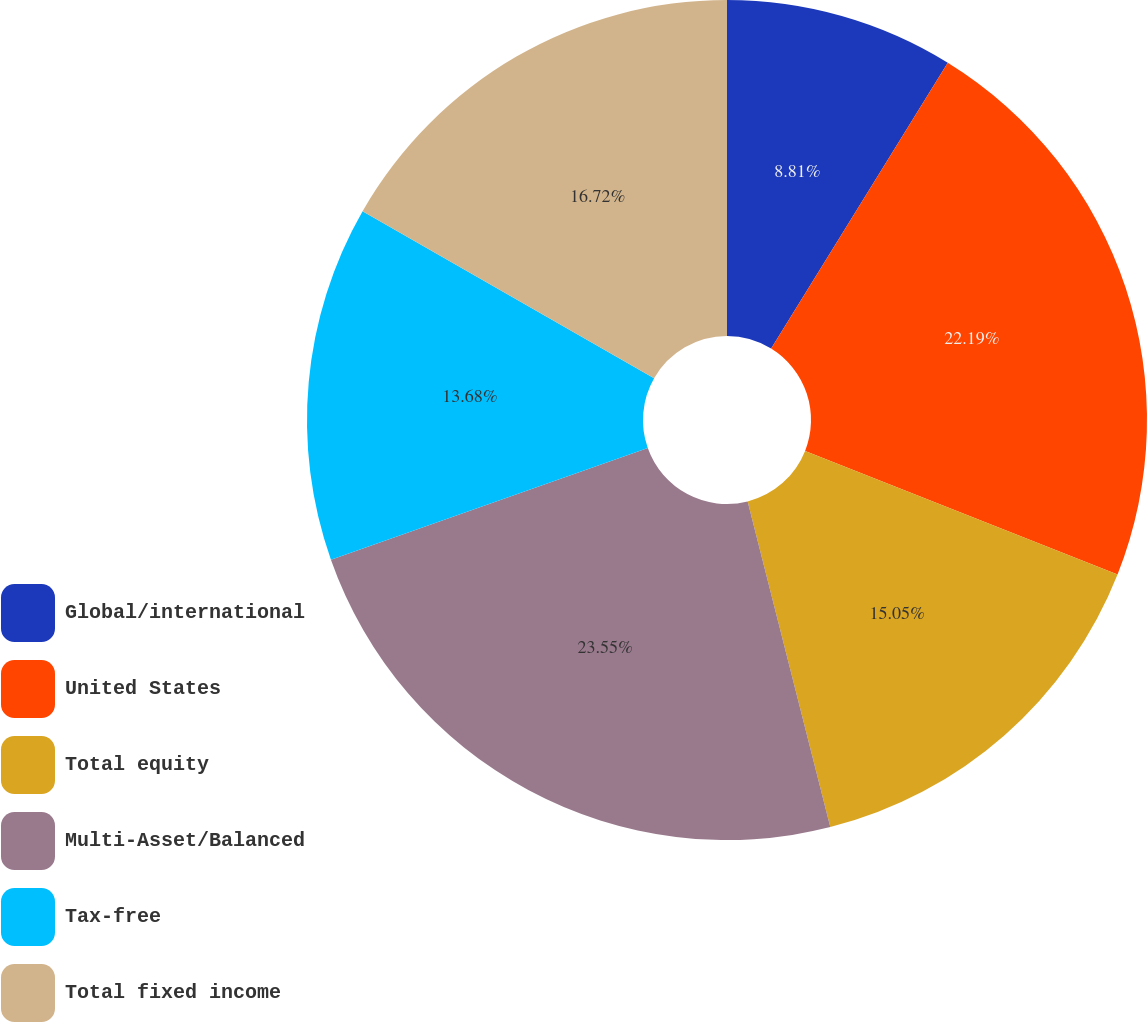Convert chart to OTSL. <chart><loc_0><loc_0><loc_500><loc_500><pie_chart><fcel>Global/international<fcel>United States<fcel>Total equity<fcel>Multi-Asset/Balanced<fcel>Tax-free<fcel>Total fixed income<nl><fcel>8.81%<fcel>22.19%<fcel>15.05%<fcel>23.56%<fcel>13.68%<fcel>16.72%<nl></chart> 